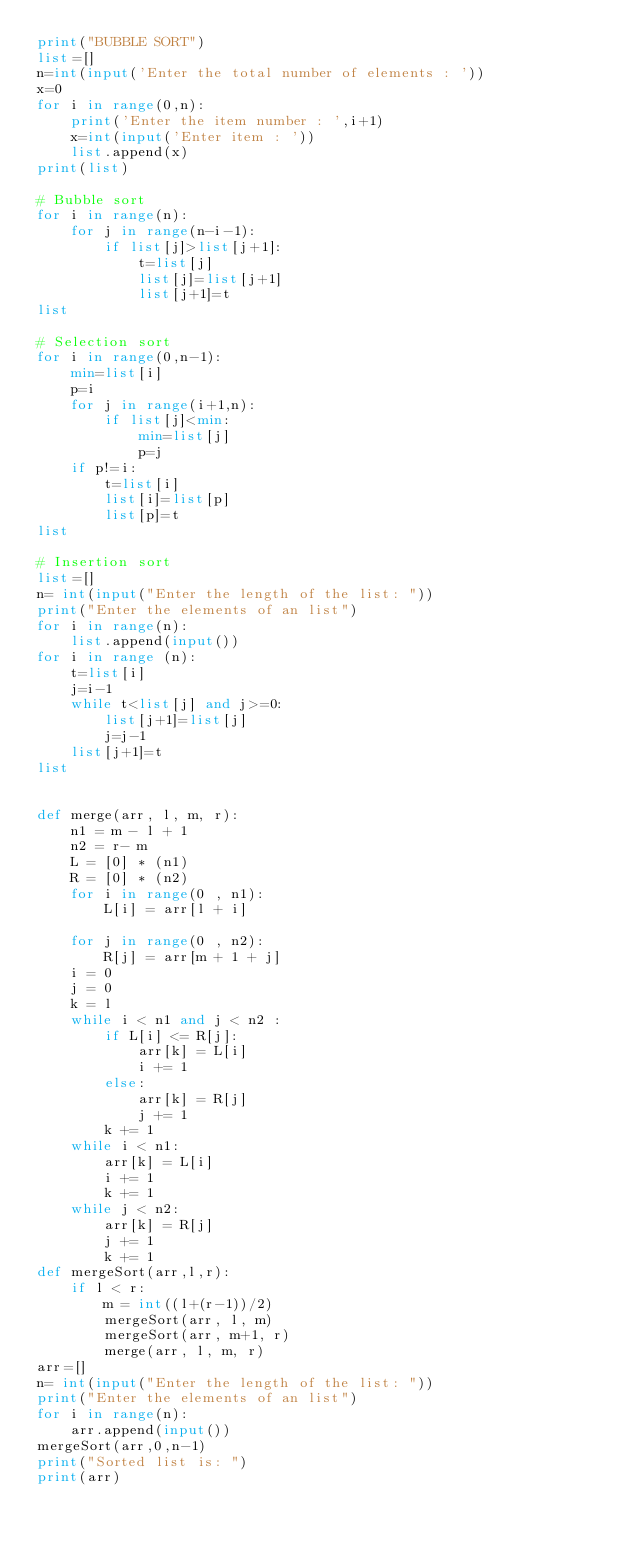<code> <loc_0><loc_0><loc_500><loc_500><_Python_>print("BUBBLE SORT")
list=[]
n=int(input('Enter the total number of elements : '))
x=0
for i in range(0,n):
    print('Enter the item number : ',i+1)
    x=int(input('Enter item : '))
    list.append(x)
print(list)

# Bubble sort
for i in range(n):
    for j in range(n-i-1):
        if list[j]>list[j+1]:
            t=list[j]
            list[j]=list[j+1]
            list[j+1]=t
list

# Selection sort
for i in range(0,n-1):
    min=list[i]
    p=i
    for j in range(i+1,n):
        if list[j]<min:
            min=list[j]
            p=j
    if p!=i:
        t=list[i]
        list[i]=list[p]
        list[p]=t
list

# Insertion sort
list=[]
n= int(input("Enter the length of the list: "))
print("Enter the elements of an list")
for i in range(n):
    list.append(input())
for i in range (n):
    t=list[i]
    j=i-1
    while t<list[j] and j>=0:
        list[j+1]=list[j]
        j=j-1
    list[j+1]=t
list


def merge(arr, l, m, r): 
    n1 = m - l + 1
    n2 = r- m 
    L = [0] * (n1) 
    R = [0] * (n2) 
    for i in range(0 , n1): 
        L[i] = arr[l + i] 
  
    for j in range(0 , n2): 
        R[j] = arr[m + 1 + j] 
    i = 0     
    j = 0     
    k = l     
    while i < n1 and j < n2 : 
        if L[i] <= R[j]: 
            arr[k] = L[i] 
            i += 1
        else: 
            arr[k] = R[j] 
            j += 1
        k += 1
    while i < n1: 
        arr[k] = L[i] 
        i += 1
        k += 1
    while j < n2: 
        arr[k] = R[j] 
        j += 1
        k += 1
def mergeSort(arr,l,r): 
    if l < r: 
        m = int((l+(r-1))/2)
        mergeSort(arr, l, m) 
        mergeSort(arr, m+1, r) 
        merge(arr, l, m, r) 
arr=[]
n= int(input("Enter the length of the list: "))
print("Enter the elements of an list")
for i in range(n):
    arr.append(input())
mergeSort(arr,0,n-1)
print("Sorted list is: ")
print(arr)


</code> 